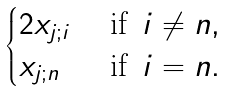<formula> <loc_0><loc_0><loc_500><loc_500>\begin{cases} 2 x _ { j ; i } & \text { if } \, i \ne n , \\ x _ { j ; n } & \text { if } \, i = n . \end{cases}</formula> 